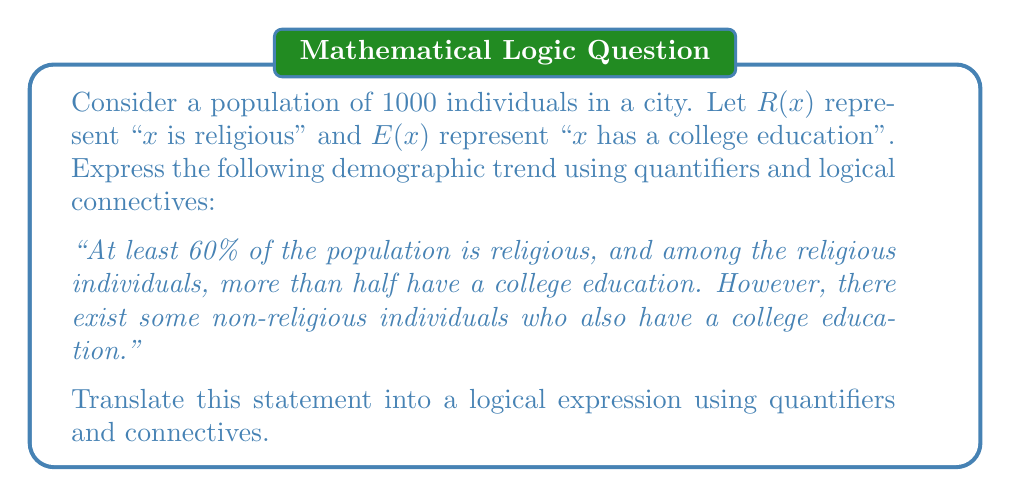Teach me how to tackle this problem. Let's break this down step-by-step:

1) "At least 60% of the population is religious":
   This can be expressed as: $$|\{x : R(x)\}| \geq 600$$
   Where $|\{x : R(x)\}|$ represents the number of religious individuals.

2) "Among the religious individuals, more than half have a college education":
   This can be written as: $$|\{x : R(x) \wedge E(x)\}| > \frac{1}{2}|\{x : R(x)\}|$$

3) "There exist some non-religious individuals who also have a college education":
   This can be expressed as: $$\exists x (\neg R(x) \wedge E(x))$$

Now, let's combine these statements using logical connectives:

$$(\exists y (|\{x : R(x)\}| \geq y \wedge y = 600)) \wedge$$
$$(\exists z (|\{x : R(x) \wedge E(x)\}| > z \wedge z = \frac{1}{2}|\{x : R(x)\}|)) \wedge$$
$$(\exists x (\neg R(x) \wedge E(x)))$$

This logical expression captures all three aspects of the demographic trend using quantifiers and logical connectives.
Answer: $$(\exists y (|\{x : R(x)\}| \geq y \wedge y = 600)) \wedge (\exists z (|\{x : R(x) \wedge E(x)\}| > z \wedge z = \frac{1}{2}|\{x : R(x)\}|)) \wedge (\exists x (\neg R(x) \wedge E(x)))$$ 